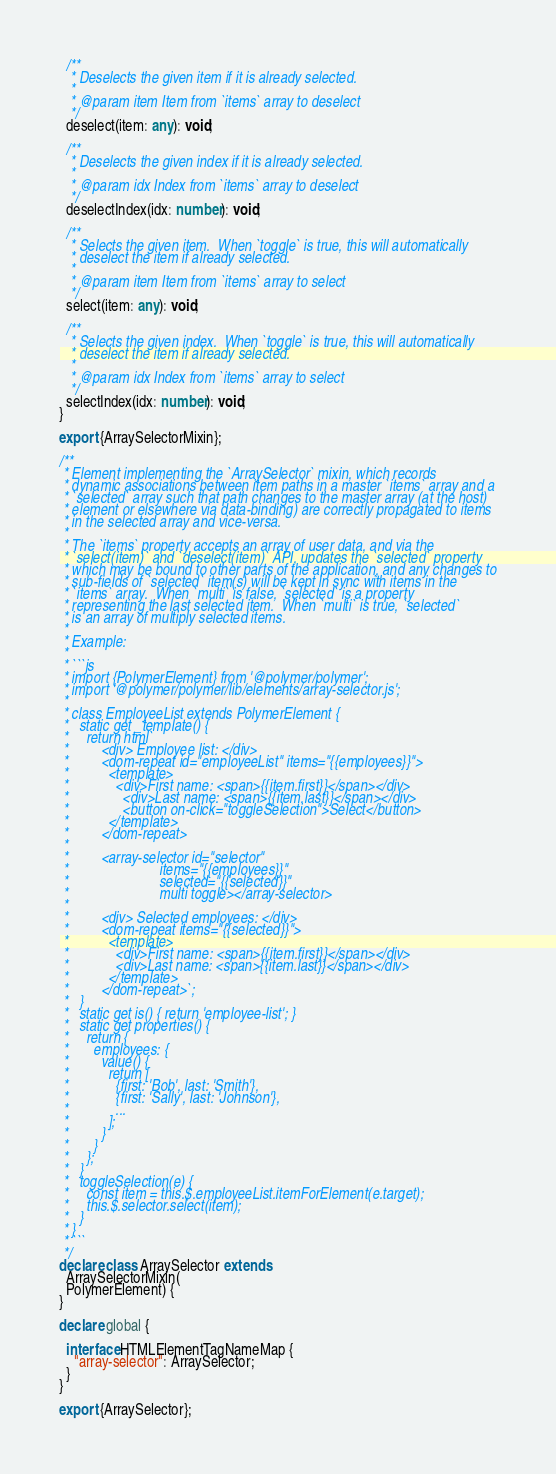Convert code to text. <code><loc_0><loc_0><loc_500><loc_500><_TypeScript_>  /**
   * Deselects the given item if it is already selected.
   *
   * @param item Item from `items` array to deselect
   */
  deselect(item: any): void;

  /**
   * Deselects the given index if it is already selected.
   *
   * @param idx Index from `items` array to deselect
   */
  deselectIndex(idx: number): void;

  /**
   * Selects the given item.  When `toggle` is true, this will automatically
   * deselect the item if already selected.
   *
   * @param item Item from `items` array to select
   */
  select(item: any): void;

  /**
   * Selects the given index.  When `toggle` is true, this will automatically
   * deselect the item if already selected.
   *
   * @param idx Index from `items` array to select
   */
  selectIndex(idx: number): void;
}

export {ArraySelectorMixin};

/**
 * Element implementing the `ArraySelector` mixin, which records
 * dynamic associations between item paths in a master `items` array and a
 * `selected` array such that path changes to the master array (at the host)
 * element or elsewhere via data-binding) are correctly propagated to items
 * in the selected array and vice-versa.
 *
 * The `items` property accepts an array of user data, and via the
 * `select(item)` and `deselect(item)` API, updates the `selected` property
 * which may be bound to other parts of the application, and any changes to
 * sub-fields of `selected` item(s) will be kept in sync with items in the
 * `items` array.  When `multi` is false, `selected` is a property
 * representing the last selected item.  When `multi` is true, `selected`
 * is an array of multiply selected items.
 *
 * Example:
 *
 * ```js
 * import {PolymerElement} from '@polymer/polymer';
 * import '@polymer/polymer/lib/elements/array-selector.js';
 *
 * class EmployeeList extends PolymerElement {
 *   static get _template() {
 *     return html`
 *         <div> Employee list: </div>
 *         <dom-repeat id="employeeList" items="{{employees}}">
 *           <template>
 *             <div>First name: <span>{{item.first}}</span></div>
 *               <div>Last name: <span>{{item.last}}</span></div>
 *               <button on-click="toggleSelection">Select</button>
 *           </template>
 *         </dom-repeat>
 *
 *         <array-selector id="selector"
 *                         items="{{employees}}"
 *                         selected="{{selected}}"
 *                         multi toggle></array-selector>
 *
 *         <div> Selected employees: </div>
 *         <dom-repeat items="{{selected}}">
 *           <template>
 *             <div>First name: <span>{{item.first}}</span></div>
 *             <div>Last name: <span>{{item.last}}</span></div>
 *           </template>
 *         </dom-repeat>`;
 *   }
 *   static get is() { return 'employee-list'; }
 *   static get properties() {
 *     return {
 *       employees: {
 *         value() {
 *           return [
 *             {first: 'Bob', last: 'Smith'},
 *             {first: 'Sally', last: 'Johnson'},
 *             ...
 *           ];
 *         }
 *       }
 *     };
 *   }
 *   toggleSelection(e) {
 *     const item = this.$.employeeList.itemForElement(e.target);
 *     this.$.selector.select(item);
 *   }
 * }
 * ```
 */
declare class ArraySelector extends
  ArraySelectorMixin(
  PolymerElement) {
}

declare global {

  interface HTMLElementTagNameMap {
    "array-selector": ArraySelector;
  }
}

export {ArraySelector};
</code> 